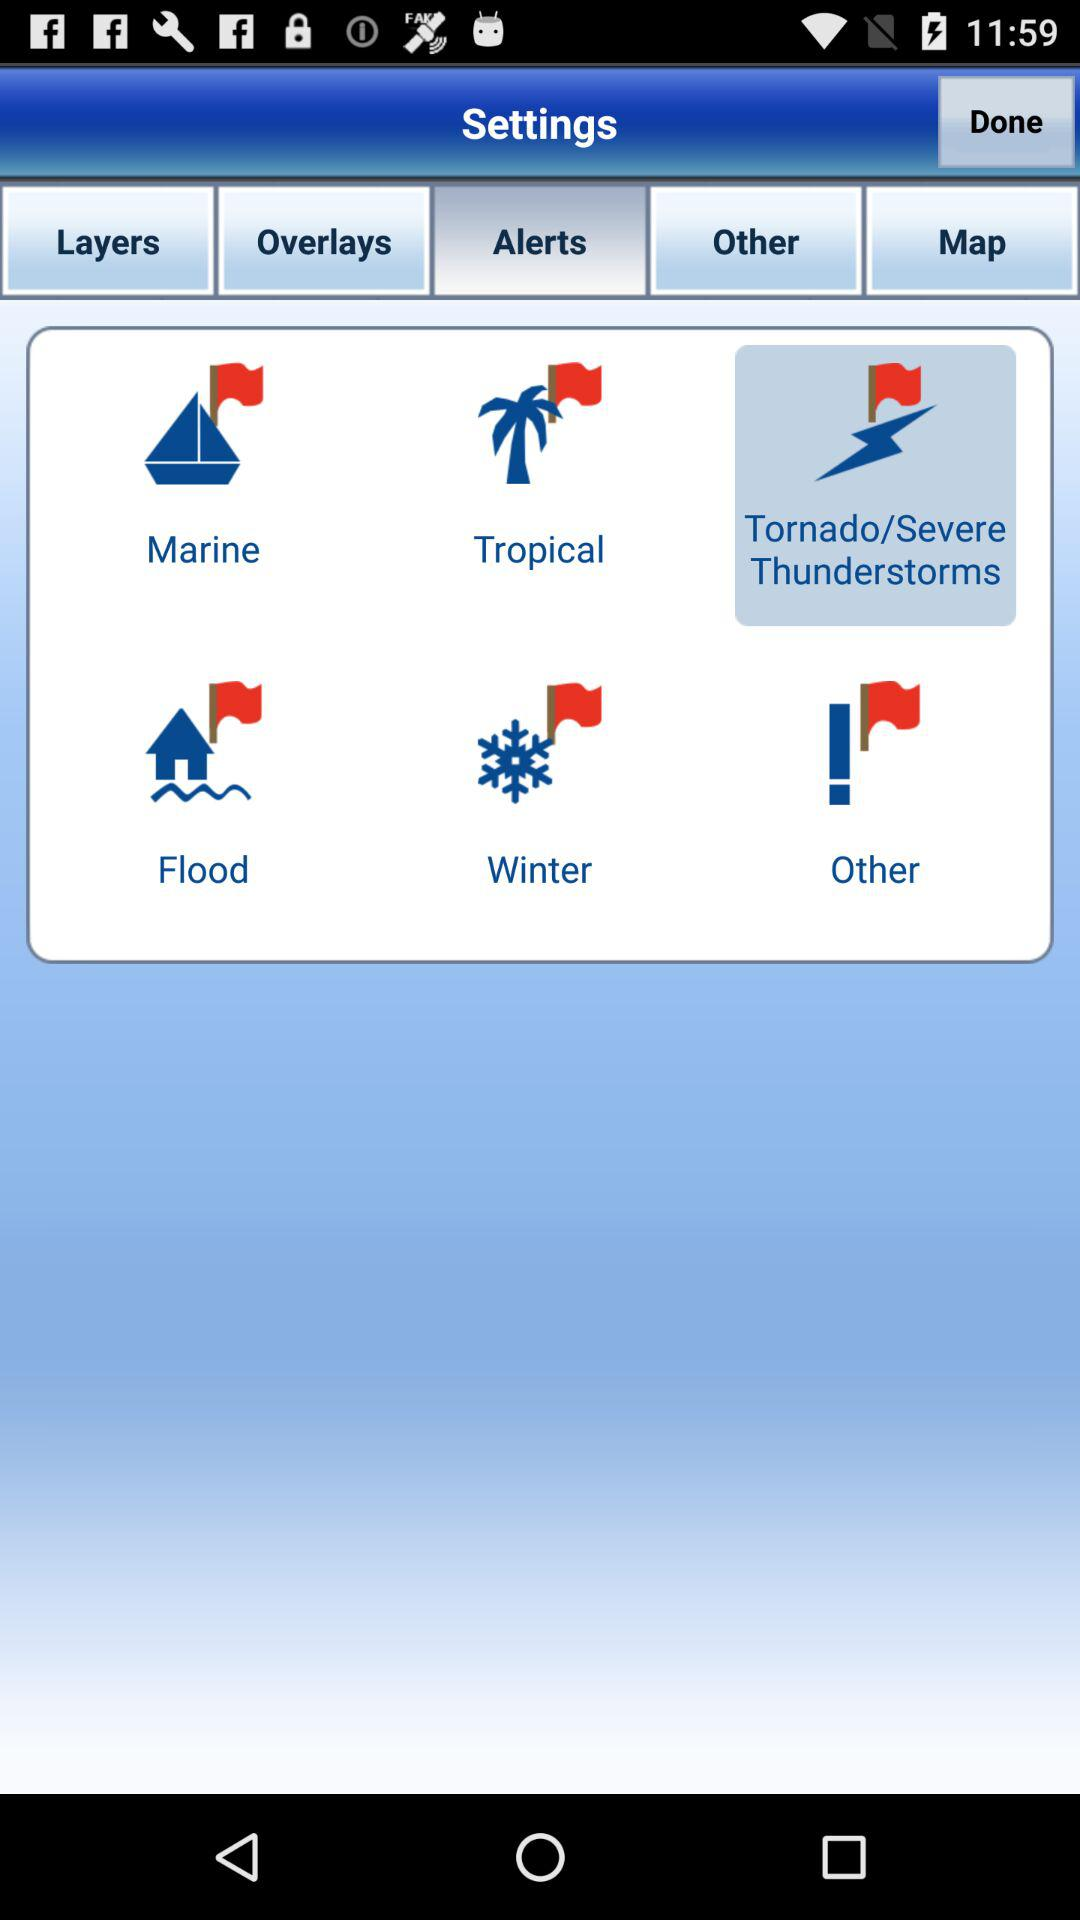What are the different available options in "Alerts"? The different available options in "Alerts" are "Marine", "Tropical", "Tornado/Severe Thunderstorms", "Flood", "Winter" and "Other". 